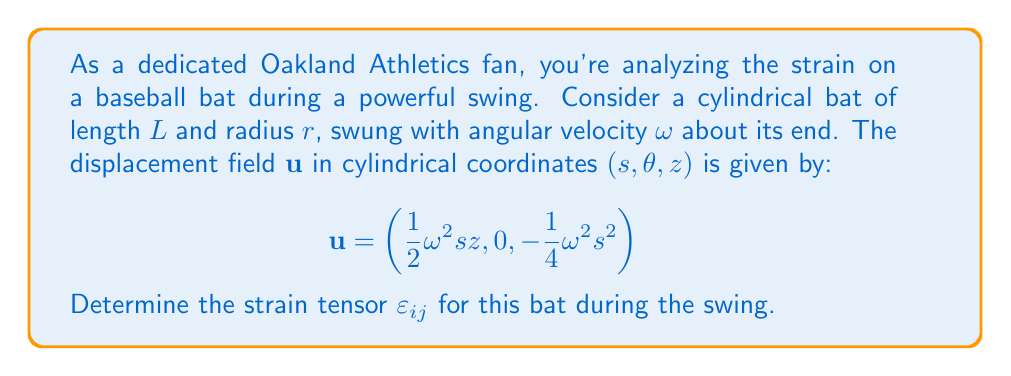Can you solve this math problem? Let's approach this step-by-step:

1) The strain tensor $\varepsilon_{ij}$ in cylindrical coordinates is given by:

   $$\varepsilon_{ij} = \frac{1}{2}\left(\frac{\partial u_i}{\partial x_j} + \frac{\partial u_j}{\partial x_i}\right)$$

2) We need to calculate each component. In cylindrical coordinates, we have:

   $$\varepsilon_{ss} = \frac{\partial u_s}{\partial s}$$
   $$\varepsilon_{\theta\theta} = \frac{1}{s}\frac{\partial u_\theta}{\partial \theta} + \frac{u_s}{s}$$
   $$\varepsilon_{zz} = \frac{\partial u_z}{\partial z}$$
   $$\varepsilon_{s\theta} = \varepsilon_{\theta s} = \frac{1}{2}\left(\frac{1}{s}\frac{\partial u_s}{\partial \theta} + \frac{\partial u_\theta}{\partial s} - \frac{u_\theta}{s}\right)$$
   $$\varepsilon_{sz} = \varepsilon_{zs} = \frac{1}{2}\left(\frac{\partial u_s}{\partial z} + \frac{\partial u_z}{\partial s}\right)$$
   $$\varepsilon_{\theta z} = \varepsilon_{z\theta} = \frac{1}{2}\left(\frac{1}{s}\frac{\partial u_z}{\partial \theta} + \frac{\partial u_\theta}{\partial z}\right)$$

3) Now, let's calculate each component:

   $$\varepsilon_{ss} = \frac{\partial}{\partial s}\left(\frac{1}{2}\omega^2 s z\right) = \frac{1}{2}\omega^2 z$$

   $$\varepsilon_{\theta\theta} = \frac{1}{s}\frac{\partial}{\partial \theta}(0) + \frac{1}{s}\left(\frac{1}{2}\omega^2 s z\right) = \frac{1}{2}\omega^2 z$$

   $$\varepsilon_{zz} = \frac{\partial}{\partial z}\left(-\frac{1}{4}\omega^2 s^2\right) = 0$$

   $$\varepsilon_{s\theta} = \varepsilon_{\theta s} = \frac{1}{2}\left(\frac{1}{s}\frac{\partial}{\partial \theta}\left(\frac{1}{2}\omega^2 s z\right) + \frac{\partial}{\partial s}(0) - \frac{0}{s}\right) = 0$$

   $$\varepsilon_{sz} = \varepsilon_{zs} = \frac{1}{2}\left(\frac{\partial}{\partial z}\left(\frac{1}{2}\omega^2 s z\right) + \frac{\partial}{\partial s}\left(-\frac{1}{4}\omega^2 s^2\right)\right) = \frac{1}{4}\omega^2 s$$

   $$\varepsilon_{\theta z} = \varepsilon_{z\theta} = \frac{1}{2}\left(\frac{1}{s}\frac{\partial}{\partial \theta}\left(-\frac{1}{4}\omega^2 s^2\right) + \frac{\partial}{\partial z}(0)\right) = 0$$

4) Therefore, the strain tensor in cylindrical coordinates is:

   $$\varepsilon_{ij} = \begin{pmatrix}
   \frac{1}{2}\omega^2 z & 0 & \frac{1}{4}\omega^2 s \\
   0 & \frac{1}{2}\omega^2 z & 0 \\
   \frac{1}{4}\omega^2 s & 0 & 0
   \end{pmatrix}$$
Answer: $$\varepsilon_{ij} = \begin{pmatrix}
\frac{1}{2}\omega^2 z & 0 & \frac{1}{4}\omega^2 s \\
0 & \frac{1}{2}\omega^2 z & 0 \\
\frac{1}{4}\omega^2 s & 0 & 0
\end{pmatrix}$$ 